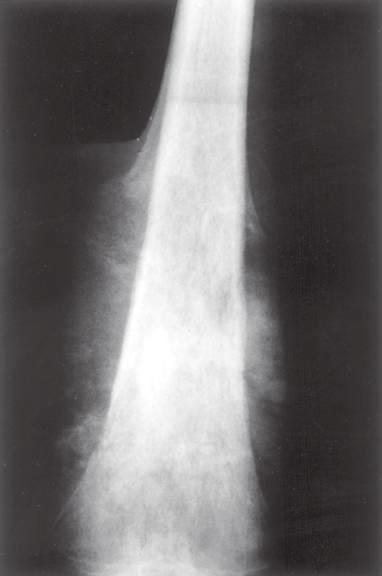what has the periosteum laid down?
Answer the question using a single word or phrase. A triangular shell of reactive bone known as a codman triangle 